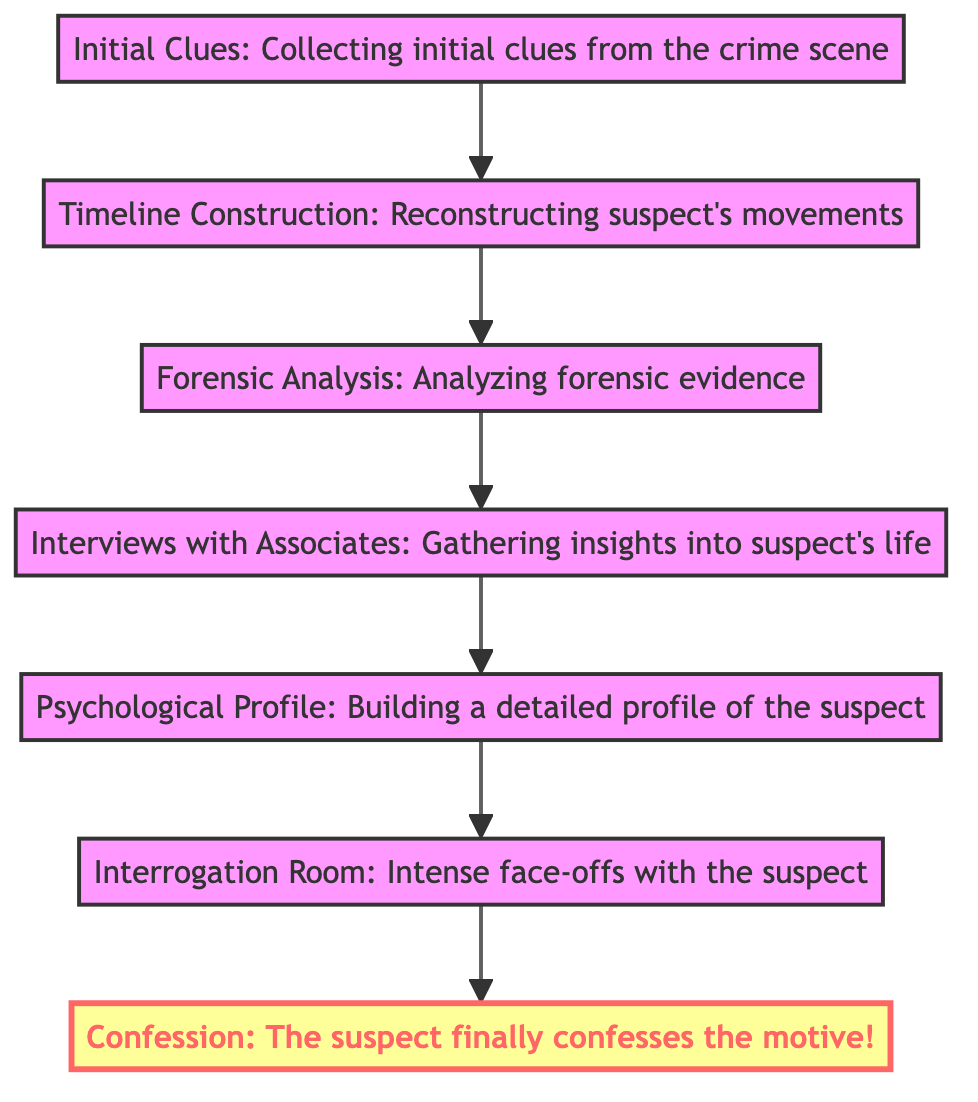What is the first stage in the flow chart? The first stage at the bottom of the flow chart is labeled "Initial Clues." It is the starting point of the analysis process leading up to the confession.
Answer: Initial Clues How many total stages are there in the diagram? By counting each of the individual stages presented in the flow chart, we see there are seven distinct stages from "Initial Clues" to "Confession."
Answer: 7 Which stage immediately follows "Forensic Analysis"? The stage that immediately follows "Forensic Analysis" is "Interviews with Associates," indicating the flow from analyzing evidence to gathering insights from the suspect’s circle.
Answer: Interviews with Associates What is the final outcome represented in the diagram? The final outcome or stage at the top of the flow chart is "Confession," which signifies the culmination of the investigative process with the suspect admitting their motive.
Answer: Confession Which two stages are directly connected to "Psychological Profile"? The "Psychological Profile" stage is directly connected to the stages "Interviews with Associates" before it and "Interrogation Room" after it, showing the relationship between gathering insights and applying psychological analysis.
Answer: Interviews with Associates and Interrogation Room How is the flow of the diagram organized? The flow of the diagram is organized in a bottom-to-top format, indicating a sequential process where each stage builds upon the last, ultimately leading to the confession.
Answer: Bottom-to-top What type of analysis begins after "Timeline Construction"? After "Timeline Construction," the next step is "Forensic Analysis," which involves examining physical evidence to support the investigative narrative.
Answer: Forensic Analysis Which stage represents the detectives' direct confrontation with the suspect? The "Interrogation Room" stage represents the setting where detectives confront the suspect directly, employing psychological tactics to elicit information.
Answer: Interrogation Room 